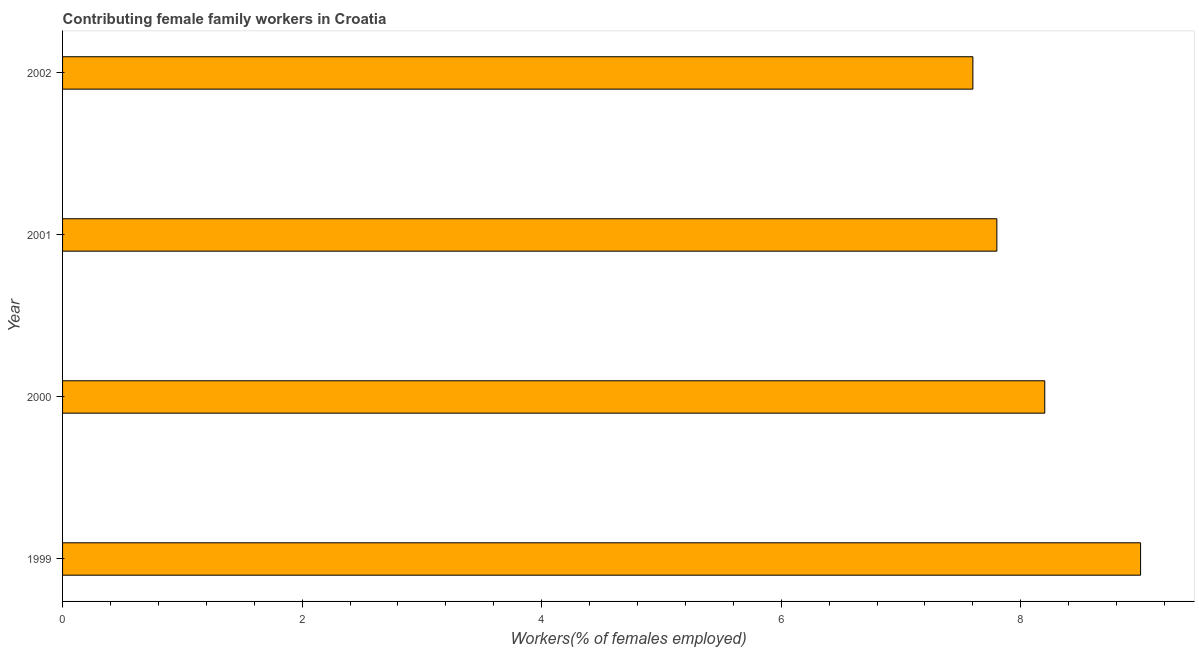Does the graph contain grids?
Keep it short and to the point. No. What is the title of the graph?
Your response must be concise. Contributing female family workers in Croatia. What is the label or title of the X-axis?
Provide a short and direct response. Workers(% of females employed). What is the contributing female family workers in 2000?
Offer a terse response. 8.2. Across all years, what is the maximum contributing female family workers?
Your answer should be very brief. 9. Across all years, what is the minimum contributing female family workers?
Offer a very short reply. 7.6. In which year was the contributing female family workers minimum?
Keep it short and to the point. 2002. What is the sum of the contributing female family workers?
Your answer should be very brief. 32.6. What is the average contributing female family workers per year?
Provide a short and direct response. 8.15. In how many years, is the contributing female family workers greater than 8.4 %?
Keep it short and to the point. 1. Do a majority of the years between 1999 and 2002 (inclusive) have contributing female family workers greater than 6.4 %?
Provide a succinct answer. Yes. What is the ratio of the contributing female family workers in 2000 to that in 2001?
Your response must be concise. 1.05. Is the sum of the contributing female family workers in 1999 and 2002 greater than the maximum contributing female family workers across all years?
Your answer should be compact. Yes. What is the difference between the highest and the lowest contributing female family workers?
Provide a succinct answer. 1.4. How many bars are there?
Your response must be concise. 4. Are all the bars in the graph horizontal?
Ensure brevity in your answer.  Yes. What is the difference between two consecutive major ticks on the X-axis?
Provide a succinct answer. 2. Are the values on the major ticks of X-axis written in scientific E-notation?
Your answer should be compact. No. What is the Workers(% of females employed) in 1999?
Ensure brevity in your answer.  9. What is the Workers(% of females employed) of 2000?
Make the answer very short. 8.2. What is the Workers(% of females employed) of 2001?
Ensure brevity in your answer.  7.8. What is the Workers(% of females employed) of 2002?
Provide a succinct answer. 7.6. What is the difference between the Workers(% of females employed) in 1999 and 2000?
Provide a short and direct response. 0.8. What is the difference between the Workers(% of females employed) in 2000 and 2001?
Your answer should be compact. 0.4. What is the difference between the Workers(% of females employed) in 2000 and 2002?
Make the answer very short. 0.6. What is the difference between the Workers(% of females employed) in 2001 and 2002?
Make the answer very short. 0.2. What is the ratio of the Workers(% of females employed) in 1999 to that in 2000?
Your answer should be very brief. 1.1. What is the ratio of the Workers(% of females employed) in 1999 to that in 2001?
Provide a short and direct response. 1.15. What is the ratio of the Workers(% of females employed) in 1999 to that in 2002?
Ensure brevity in your answer.  1.18. What is the ratio of the Workers(% of females employed) in 2000 to that in 2001?
Offer a very short reply. 1.05. What is the ratio of the Workers(% of females employed) in 2000 to that in 2002?
Make the answer very short. 1.08. What is the ratio of the Workers(% of females employed) in 2001 to that in 2002?
Keep it short and to the point. 1.03. 